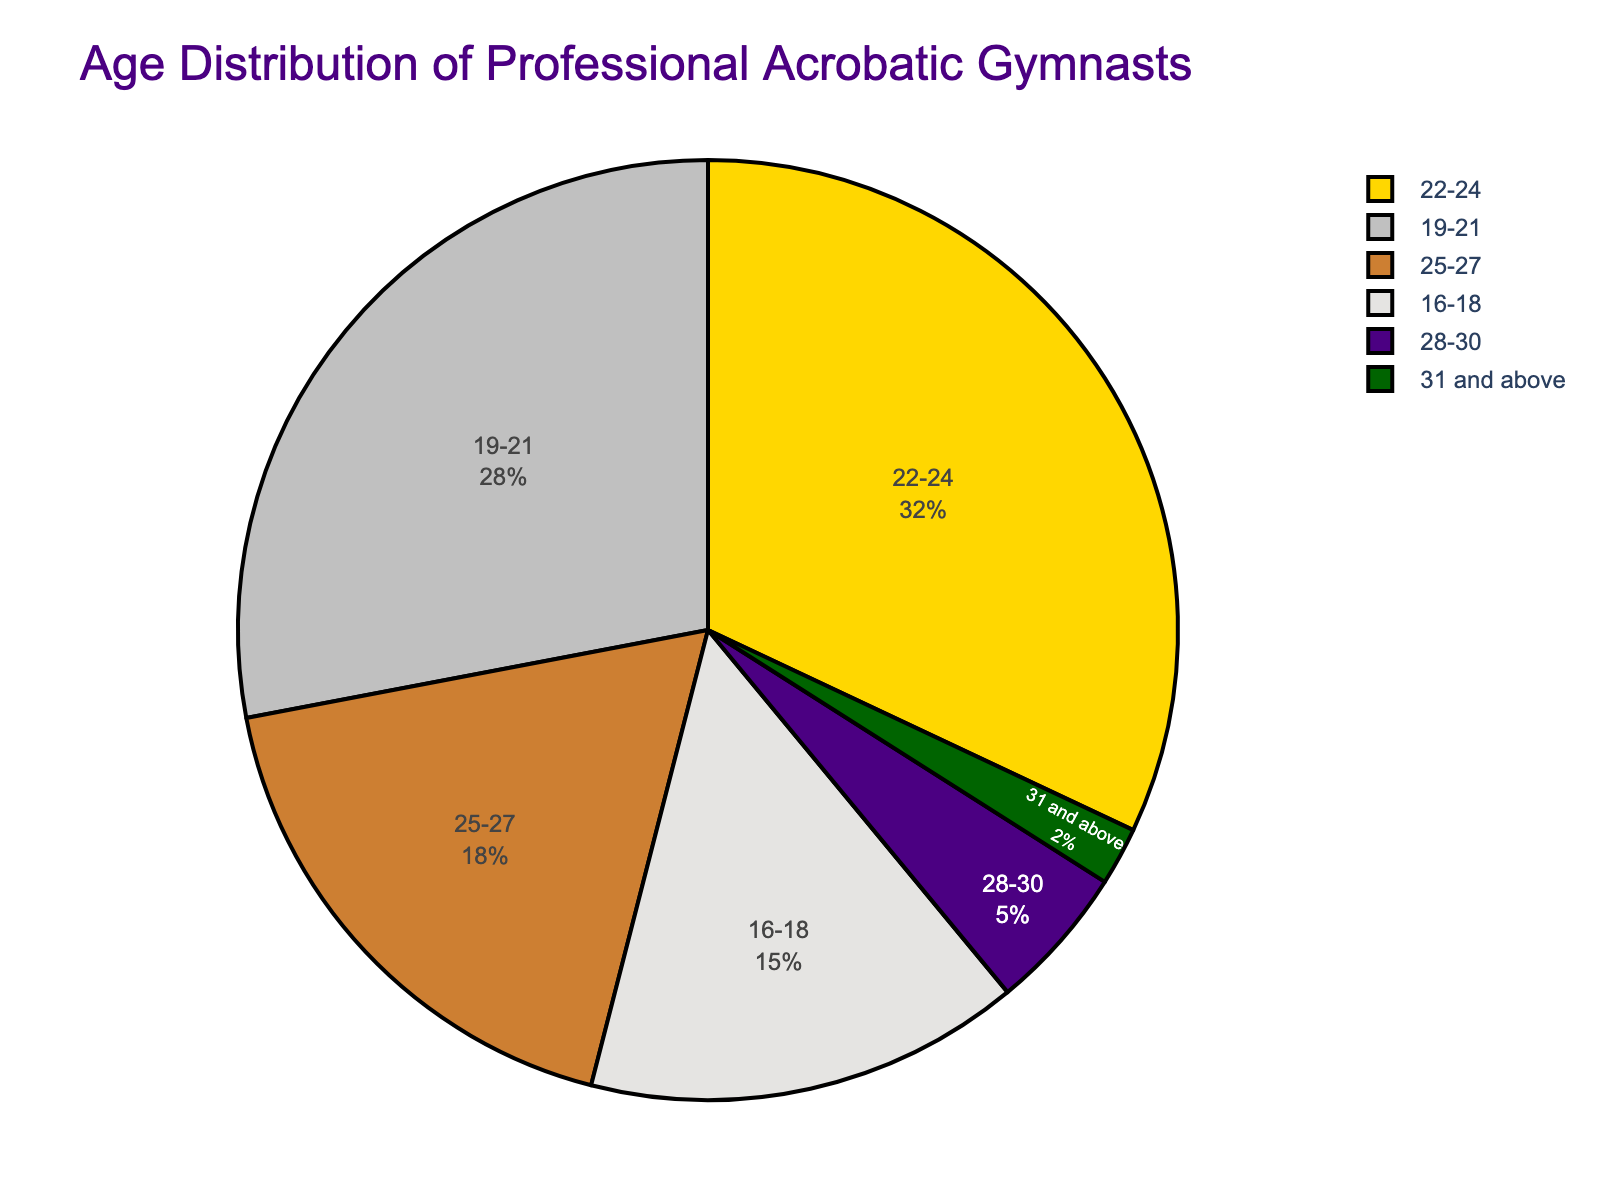What age group has the highest percentage of professional acrobatic gymnasts? By looking at the pie chart, we identify that the 22-24 age group has the largest segment. This is visually shown as the largest slice by area.
Answer: 22-24 Which two age groups combined make up more than half of the distribution? The two largest slices in the pie chart are 22-24 and 19-21. Adding their percentages (32% and 28%) gives a total of 60%, which is more than half (50%).
Answer: 22-24 and 19-21 How much greater is the percentage of gymnasts aged 22-24 compared to those aged 28-30? The percentage for 22-24 is 32%, and for 28-30 it is 5%. The difference between them is 32% - 5% = 27%.
Answer: 27% What is the color used to represent the age group 25-27? By looking at the color scheme in the pie chart, the 25-27 age group is represented by the segment colored in green.
Answer: Green If combined, what percentage of gymnasts are aged either 16-18 or 25-27? The percentage for 16-18 is 15%, and for 25-27 it is 18%. Adding these up gives 15% + 18% = 33%.
Answer: 33% Which age group has the smallest representation, and what is its percentage? The smallest slice in the pie chart represents the 31 and above age group, which accounts for 2%.
Answer: 31 and above, 2% How does the percentage of gymnasts aged 19-21 compare to the sum of gymnasts aged 16-18 and 28-30? The percentage for 19-21 is 28%. The combined percentage of 16-18 and 28-30 is 15% + 5% = 20%. Thus, 28% is greater than 20%.
Answer: 28% is greater List all age groups that comprise less than 20% each of the gymnasts. From the pie chart, the age groups 16-18 (15%), 25-27 (18%), 28-30 (5%), and 31 and above (2%) each comprise less than 20%.
Answer: 16-18, 25-27, 28-30, 31 and above What is the combined percentage for gymnasts aged between 19 and 27? Combining the percentages of 19-21 (28%), 22-24 (32%), and 25-27 (18%) gives 28% + 32% + 18% = 78%.
Answer: 78% 